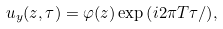<formula> <loc_0><loc_0><loc_500><loc_500>u _ { y } ( z , \tau ) = \varphi ( z ) \exp { \left ( { i 2 \pi T \tau } / { } \right ) } ,</formula> 